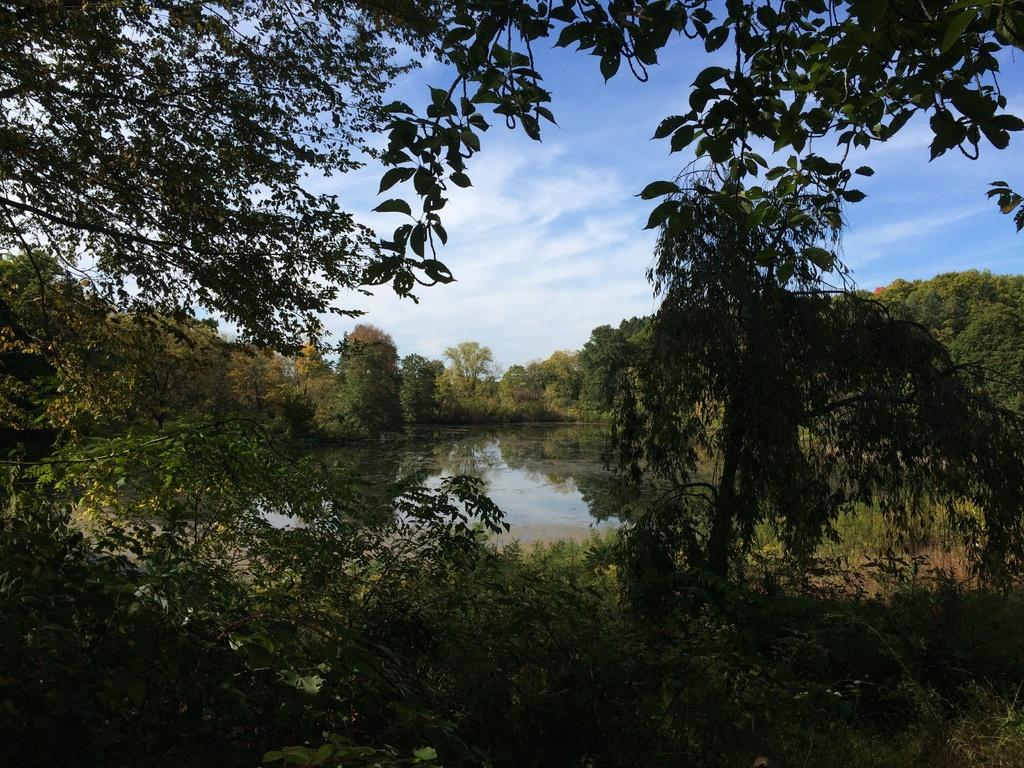What type of vegetation can be seen in the image? There are trees in the image. What is the color of the trees in the image? The trees are green in color. What else is visible in the image besides the trees? There is water visible in the image. What is the color of the sky in the image? The sky is blue and white in color. What type of fowl can be seen swimming in the water in the image? There are no fowl visible in the image; it only shows trees, water, and the sky. What type of pie is being served on a plate in the image? There is no pie present in the image. 